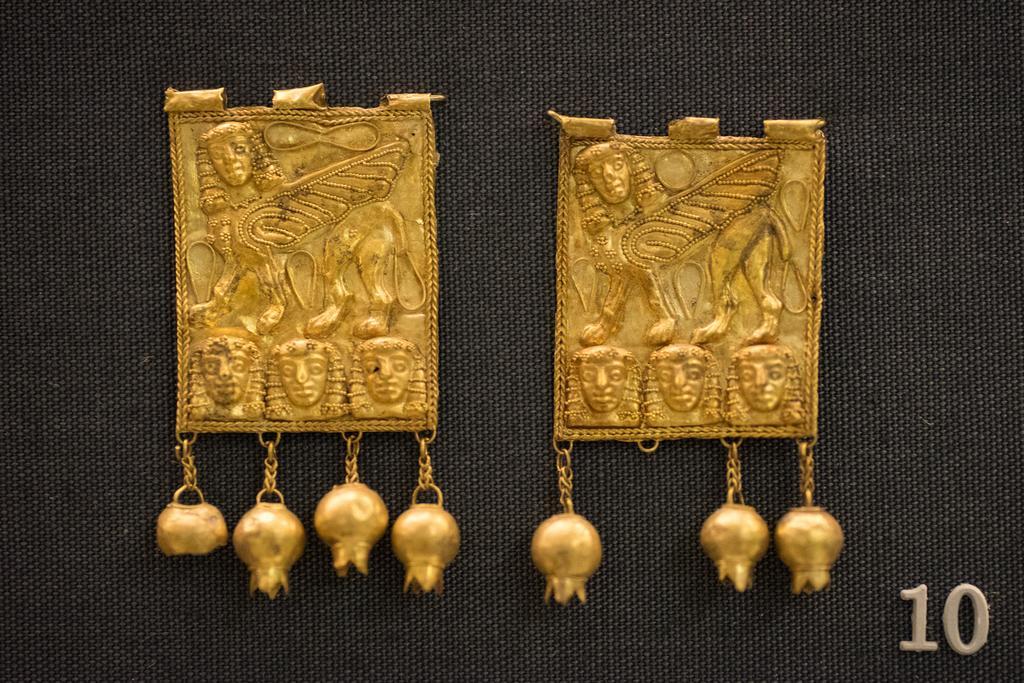How would you summarize this image in a sentence or two? In this picture I can observe two objects which are looking like ornaments. In the bottom right side I can observe a number. 